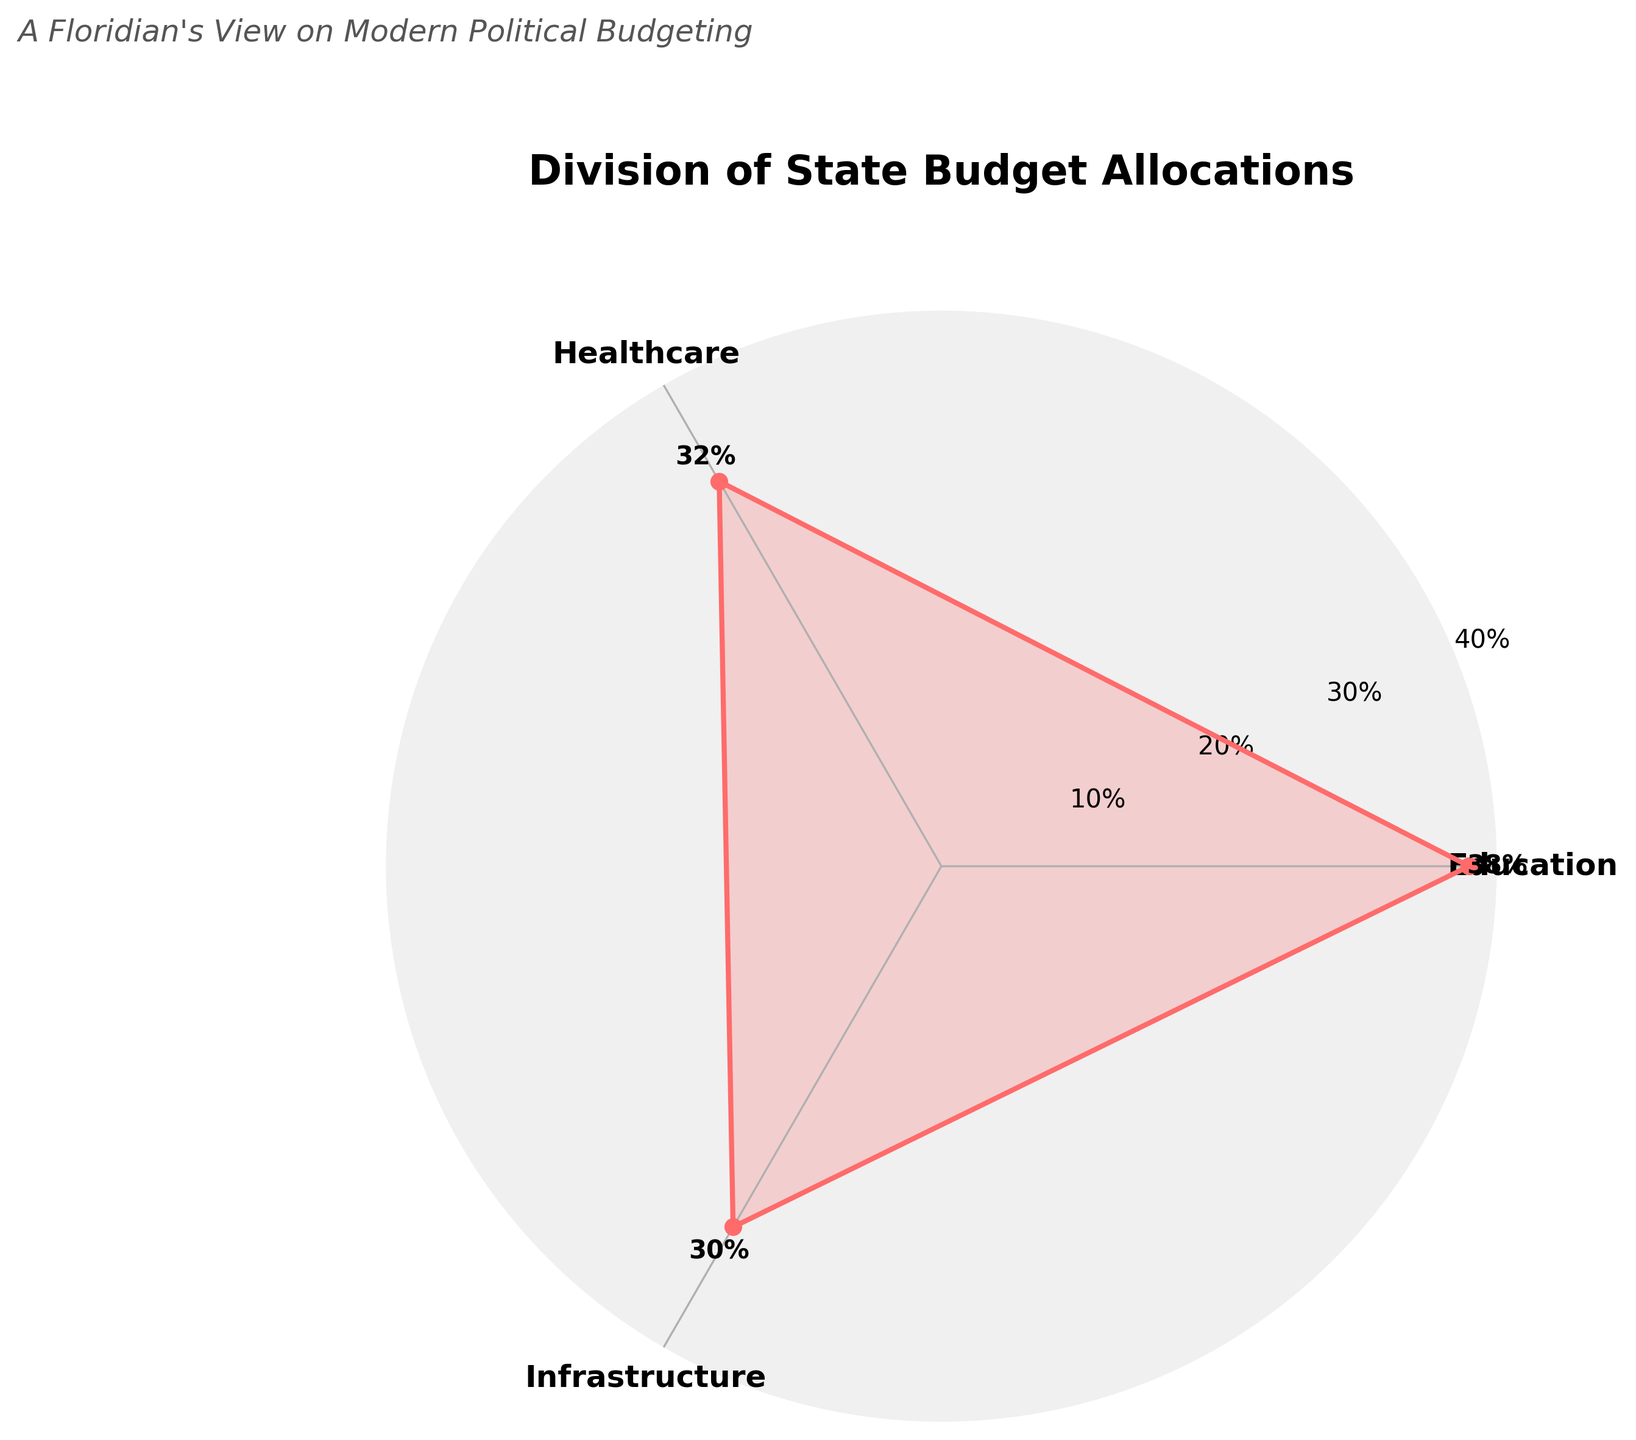what is the percentage allocation for Education? The percentage allocation for Education is read directly from the chart, where Education is labeled and the associated percentage is shown.
Answer: 38% What is the total percentage for Healthcare and Infrastructure combined? The percentages for Healthcare and Infrastructure are 32% and 30%, respectively. Adding these values gives 32% + 30% = 62%.
Answer: 62% Which sector receives the highest percentage allocation in the state budget? The chart shows the percentages for each sector, with Education being the highest at 38%.
Answer: Education How many sectors have more than 30% allocation? By examining the percentages allocated to each sector, we identify that both Education (38%) and Healthcare (32%) have more than 30% allocation.
Answer: 2 sectors Does any sector have exactly one-third of the state budget? The proportions for each sector are shown: Education (38%), Healthcare (32%), and Infrastructure (30%). None of these are exactly one-third, which is approximately 33.33%.
Answer: No What is the difference in percentage allocation between Education and Infrastructure? The percentage for Education is 38% and for Infrastructure is 30%. The difference is calculated as 38% - 30% = 8%.
Answer: 8% If the percentage for each sector represents their respective importance, which sector is the least prioritized? By comparing the percentages, Infrastructure has the lowest allocation at 30%, indicating it is the least prioritized sector.
Answer: Infrastructure How much more is the percentage allocation for Education compared to Healthcare? The chart shows that Education has 38% and Healthcare has 32%. The difference is 38% - 32% = 6%.
Answer: 6% What is the sector with the second-highest allocation, and what percentage do they receive? By identifying the allocations, Education has the highest at 38%, and Healthcare follows with the second-highest allocation of 32%.
Answer: Healthcare, 32% What is the average percentage allocation across all sectors? Sum the percentages for all sectors and divide by the number of sectors: (38% + 32% + 30%) / 3 = 100% / 3 = 33.33%.
Answer: 33.33% 